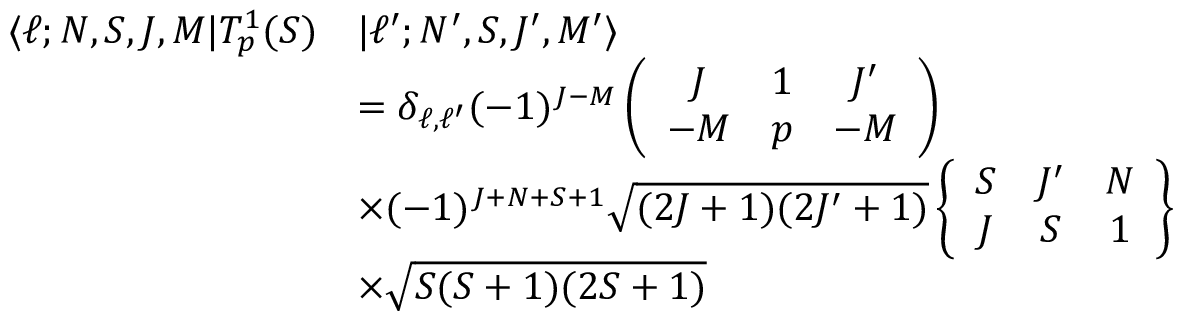Convert formula to latex. <formula><loc_0><loc_0><loc_500><loc_500>\begin{array} { r l } { \langle \ell ; N , S , J , M | T _ { p } ^ { 1 } ( S ) } & { | \ell ^ { \prime } ; N ^ { \prime } , S , J ^ { \prime } , M ^ { \prime } \rangle } \\ & { = \delta _ { \ell , \ell ^ { \prime } } ( - 1 ) ^ { J - M } \left ( \begin{array} { c c c } { J } & { 1 } & { J ^ { \prime } } \\ { - M } & { p } & { - M } \end{array} \right ) } \\ & { \times ( - 1 ) ^ { J + N + S + 1 } \sqrt { ( 2 J + 1 ) ( 2 J ^ { \prime } + 1 ) } \left \{ \begin{array} { c c c } { S } & { J ^ { \prime } } & { N } \\ { J } & { S } & { 1 } \end{array} \right \} } \\ & { \times \sqrt { S ( S + 1 ) ( 2 S + 1 ) } } \end{array}</formula> 